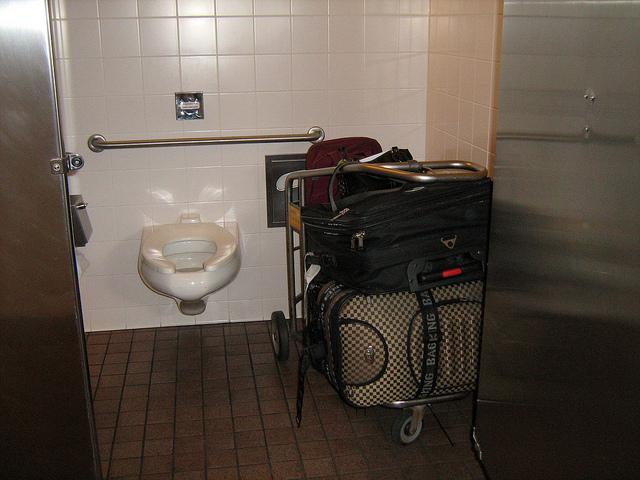How many toilets are there?
Be succinct. 1. Is there a safety bar in the bathroom?
Write a very short answer. Yes. Where is the toilet paper?
Give a very brief answer. Wall. What is the wall made of?
Concise answer only. Tile. 